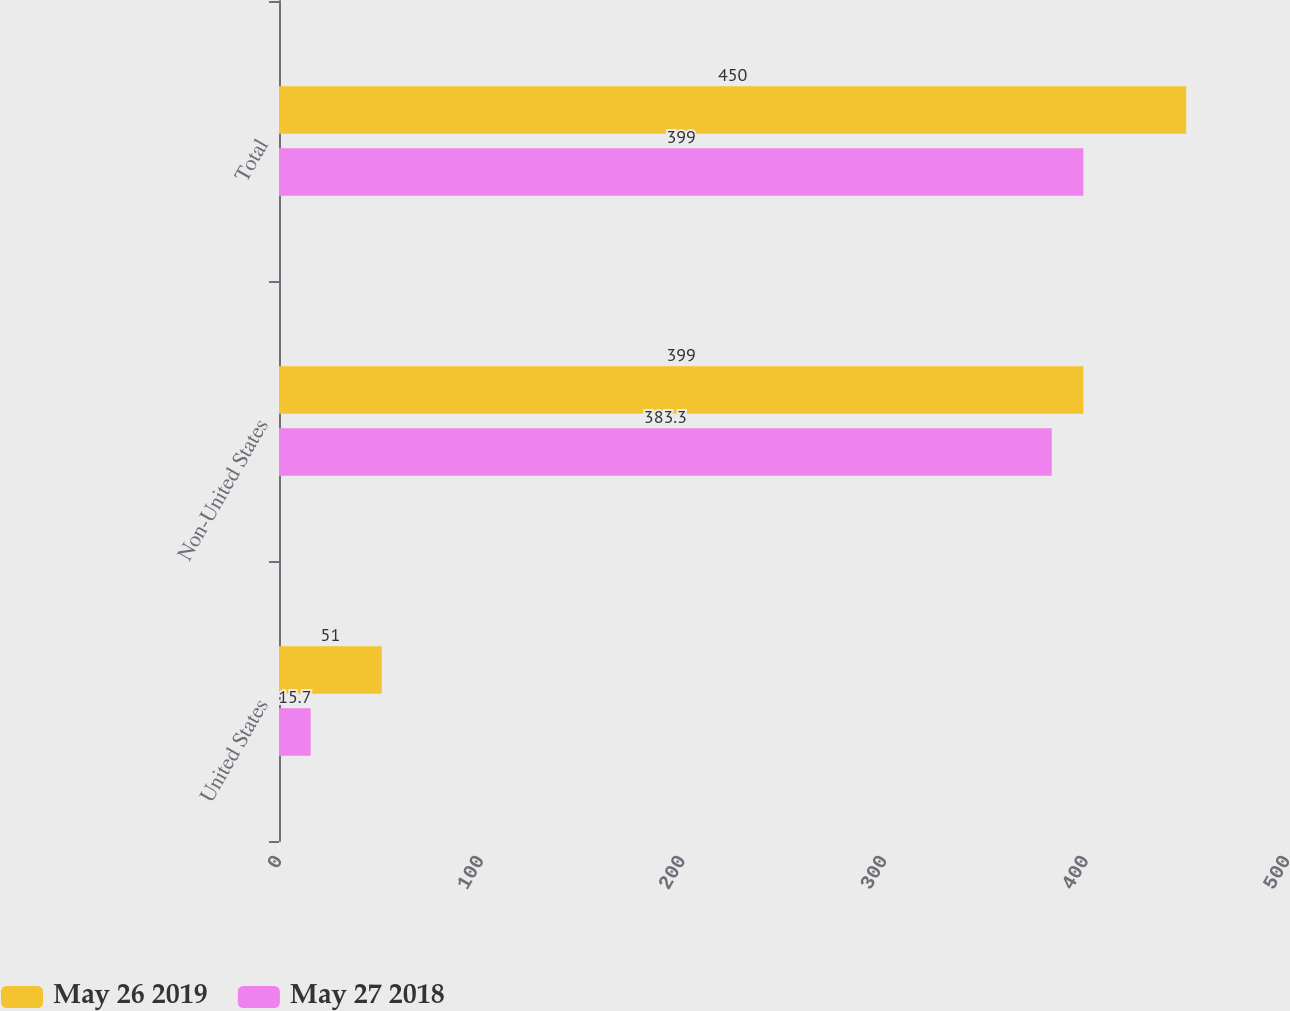<chart> <loc_0><loc_0><loc_500><loc_500><stacked_bar_chart><ecel><fcel>United States<fcel>Non-United States<fcel>Total<nl><fcel>May 26 2019<fcel>51<fcel>399<fcel>450<nl><fcel>May 27 2018<fcel>15.7<fcel>383.3<fcel>399<nl></chart> 